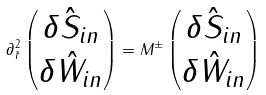Convert formula to latex. <formula><loc_0><loc_0><loc_500><loc_500>\partial ^ { 2 } _ { \tilde { r } } \left ( \begin{matrix} \delta \hat { S } _ { i n } \\ \delta \hat { W } _ { i n } \end{matrix} \right ) = { M } ^ { \pm } \left ( \begin{matrix} \delta \hat { S } _ { i n } \\ \delta \hat { W } _ { i n } \end{matrix} \right )</formula> 